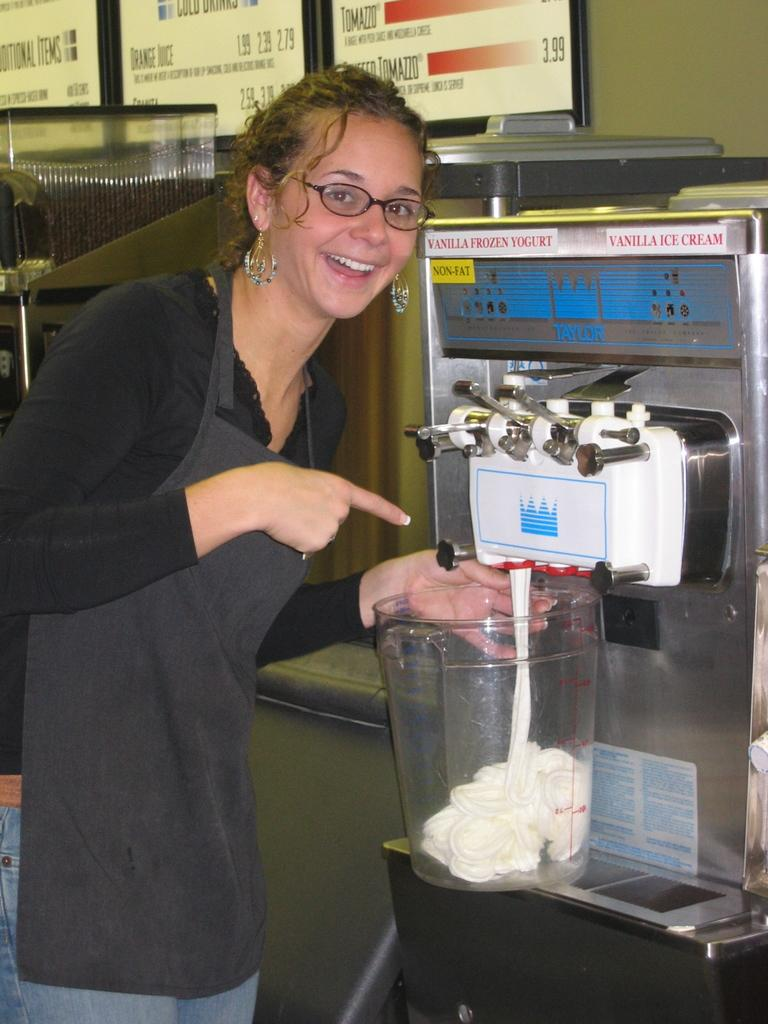Provide a one-sentence caption for the provided image. A woman fills a large container from a vanilla ice cream and yogurt machine. 